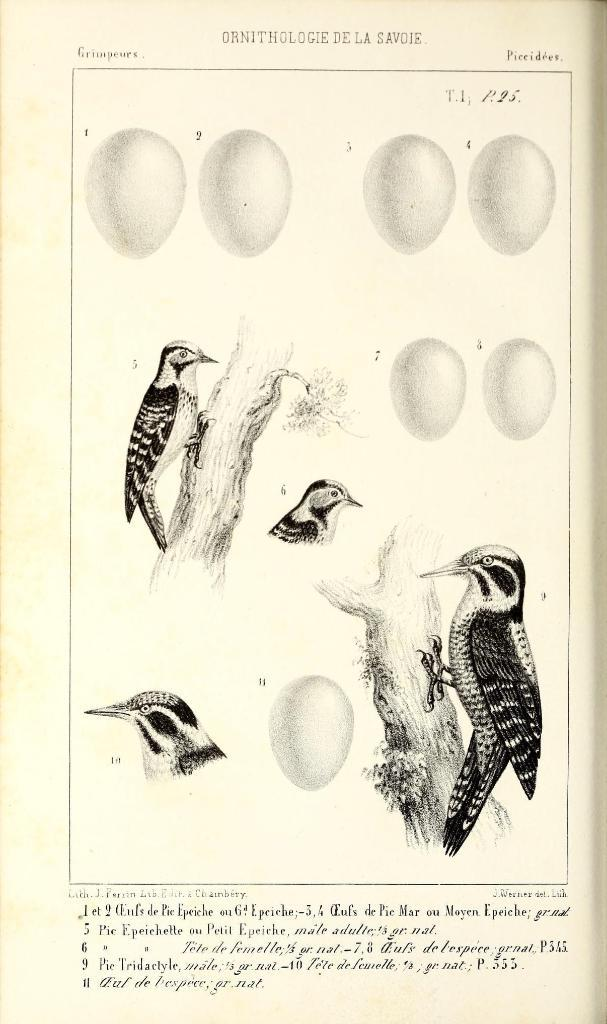What is depicted on the paper in the image? There are birds, a branch, and eggs on the paper in the image. Can you describe the birds on the paper? The birds are depicted on the paper, but no specific details about their appearance or behavior are provided. What else is present on the paper besides the birds? There is a branch and eggs on the paper. What type of sign can be seen hanging from the branch in the image? There is no sign present in the image; it only features birds, a branch, and eggs on the paper. Can you describe the tongue of the bird in the image? There is no bird's tongue visible in the image, as the birds are depicted on a flat paper and do not have any visible facial features. 